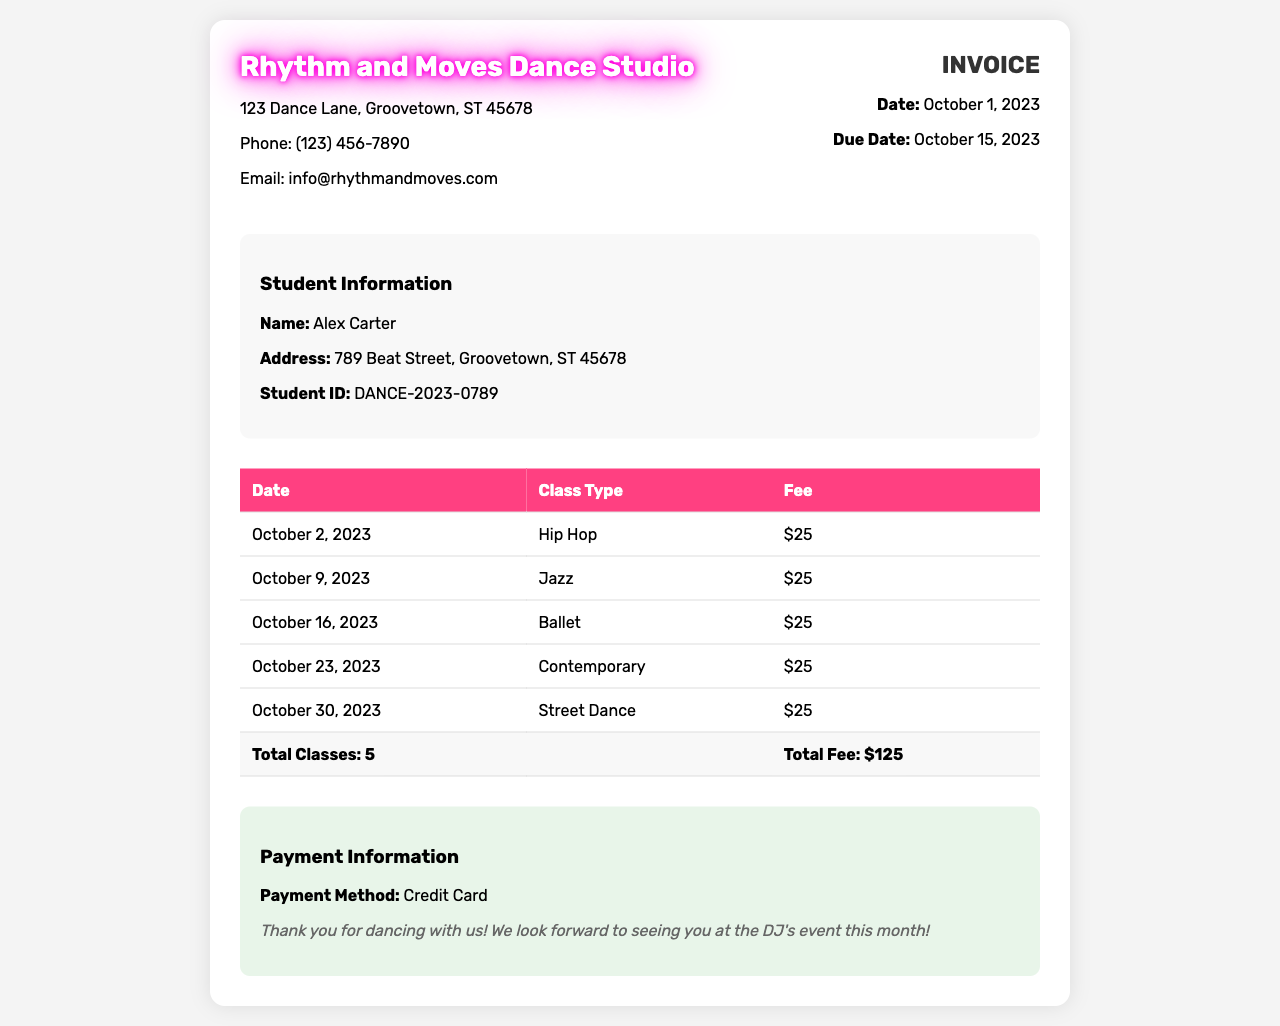What is the name of the dance studio? The name of the dance studio is listed in the header of the document.
Answer: Rhythm and Moves Dance Studio When is the invoice due? The due date for the invoice is specified in the invoice details section.
Answer: October 15, 2023 How many classes are listed in the invoice? The total number of classes is provided in the total row of the table.
Answer: 5 What is the fee for a single class? The fee for each class type is outlined in the table under the "Fee" column.
Answer: $25 What is the total fee for all classes? The total fee is described in the last row of the table, combining all the individual class fees.
Answer: $125 What class type is on October 16, 2023? The class type for the specific date is mentioned in the table corresponding to October 16.
Answer: Ballet What payment method is mentioned in the invoice? The payment method can be found in the payment information section of the document.
Answer: Credit Card What is the student's name? The student's name is identified in the student information section of the invoice.
Answer: Alex Carter What is the student ID? The student ID is provided in the student information section of the invoice.
Answer: DANCE-2023-0789 